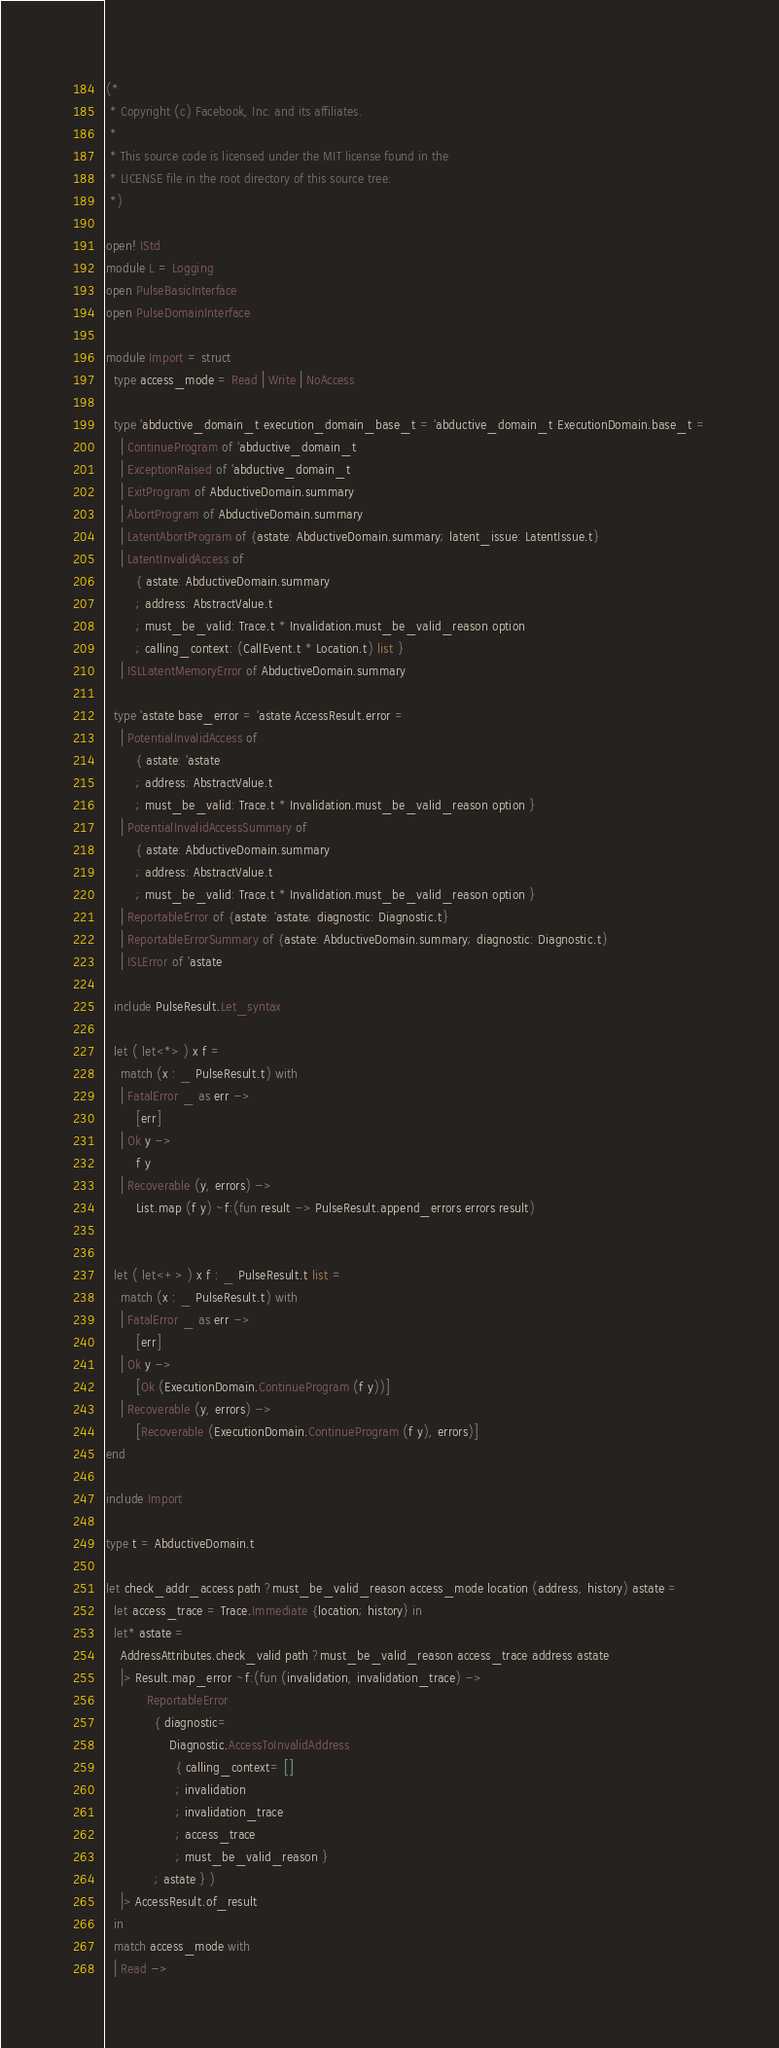Convert code to text. <code><loc_0><loc_0><loc_500><loc_500><_OCaml_>(*
 * Copyright (c) Facebook, Inc. and its affiliates.
 *
 * This source code is licensed under the MIT license found in the
 * LICENSE file in the root directory of this source tree.
 *)

open! IStd
module L = Logging
open PulseBasicInterface
open PulseDomainInterface

module Import = struct
  type access_mode = Read | Write | NoAccess

  type 'abductive_domain_t execution_domain_base_t = 'abductive_domain_t ExecutionDomain.base_t =
    | ContinueProgram of 'abductive_domain_t
    | ExceptionRaised of 'abductive_domain_t
    | ExitProgram of AbductiveDomain.summary
    | AbortProgram of AbductiveDomain.summary
    | LatentAbortProgram of {astate: AbductiveDomain.summary; latent_issue: LatentIssue.t}
    | LatentInvalidAccess of
        { astate: AbductiveDomain.summary
        ; address: AbstractValue.t
        ; must_be_valid: Trace.t * Invalidation.must_be_valid_reason option
        ; calling_context: (CallEvent.t * Location.t) list }
    | ISLLatentMemoryError of AbductiveDomain.summary

  type 'astate base_error = 'astate AccessResult.error =
    | PotentialInvalidAccess of
        { astate: 'astate
        ; address: AbstractValue.t
        ; must_be_valid: Trace.t * Invalidation.must_be_valid_reason option }
    | PotentialInvalidAccessSummary of
        { astate: AbductiveDomain.summary
        ; address: AbstractValue.t
        ; must_be_valid: Trace.t * Invalidation.must_be_valid_reason option }
    | ReportableError of {astate: 'astate; diagnostic: Diagnostic.t}
    | ReportableErrorSummary of {astate: AbductiveDomain.summary; diagnostic: Diagnostic.t}
    | ISLError of 'astate

  include PulseResult.Let_syntax

  let ( let<*> ) x f =
    match (x : _ PulseResult.t) with
    | FatalError _ as err ->
        [err]
    | Ok y ->
        f y
    | Recoverable (y, errors) ->
        List.map (f y) ~f:(fun result -> PulseResult.append_errors errors result)


  let ( let<+> ) x f : _ PulseResult.t list =
    match (x : _ PulseResult.t) with
    | FatalError _ as err ->
        [err]
    | Ok y ->
        [Ok (ExecutionDomain.ContinueProgram (f y))]
    | Recoverable (y, errors) ->
        [Recoverable (ExecutionDomain.ContinueProgram (f y), errors)]
end

include Import

type t = AbductiveDomain.t

let check_addr_access path ?must_be_valid_reason access_mode location (address, history) astate =
  let access_trace = Trace.Immediate {location; history} in
  let* astate =
    AddressAttributes.check_valid path ?must_be_valid_reason access_trace address astate
    |> Result.map_error ~f:(fun (invalidation, invalidation_trace) ->
           ReportableError
             { diagnostic=
                 Diagnostic.AccessToInvalidAddress
                   { calling_context= []
                   ; invalidation
                   ; invalidation_trace
                   ; access_trace
                   ; must_be_valid_reason }
             ; astate } )
    |> AccessResult.of_result
  in
  match access_mode with
  | Read -></code> 